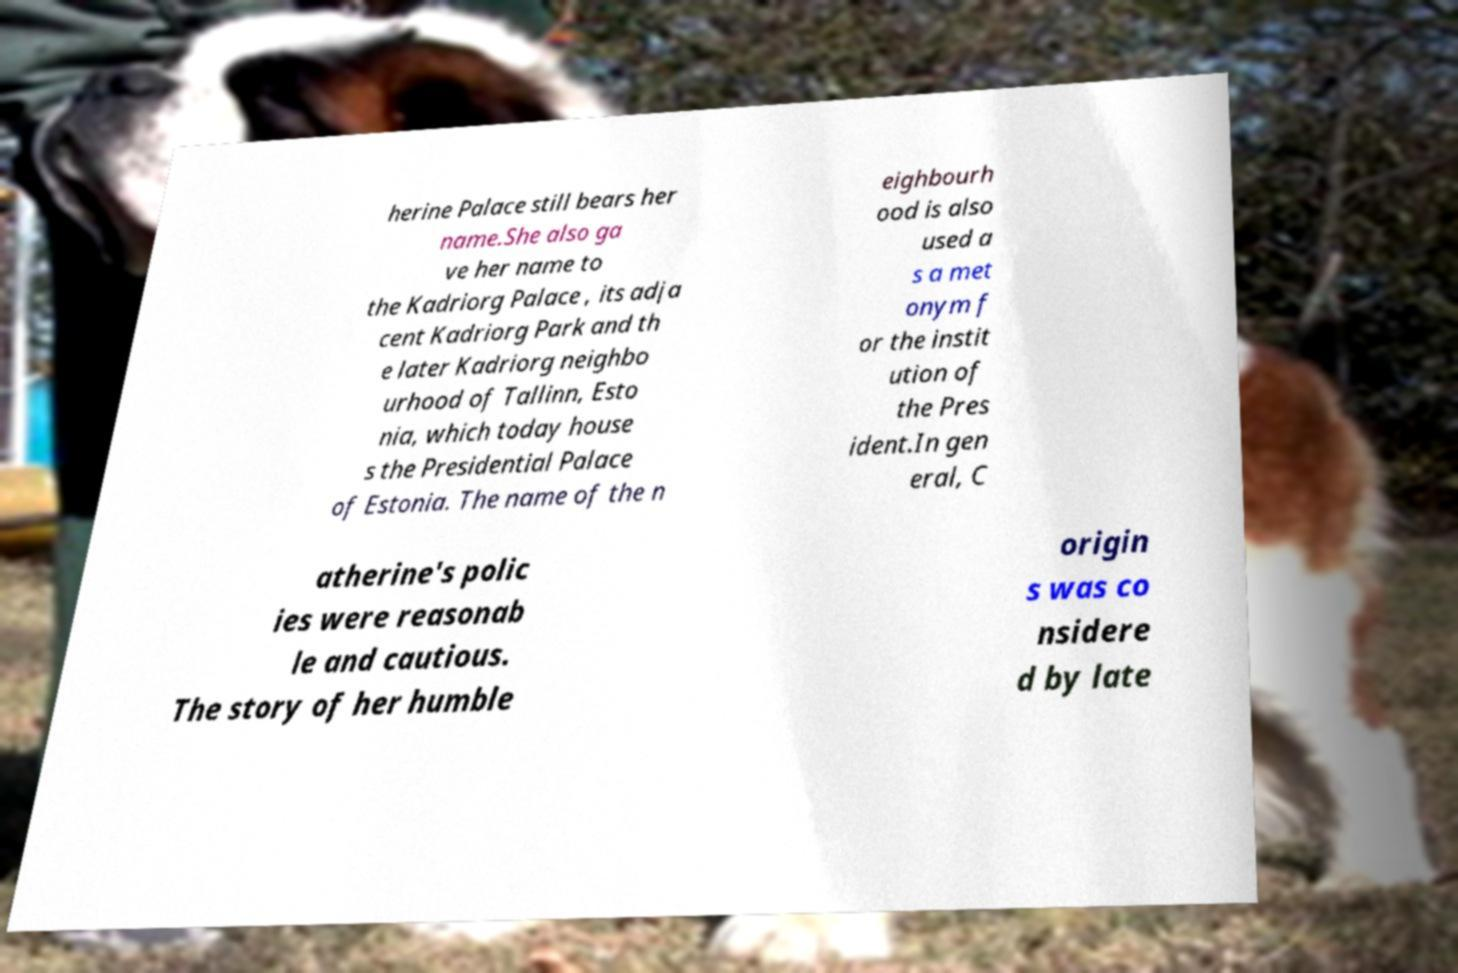Can you read and provide the text displayed in the image?This photo seems to have some interesting text. Can you extract and type it out for me? herine Palace still bears her name.She also ga ve her name to the Kadriorg Palace , its adja cent Kadriorg Park and th e later Kadriorg neighbo urhood of Tallinn, Esto nia, which today house s the Presidential Palace of Estonia. The name of the n eighbourh ood is also used a s a met onym f or the instit ution of the Pres ident.In gen eral, C atherine's polic ies were reasonab le and cautious. The story of her humble origin s was co nsidere d by late 